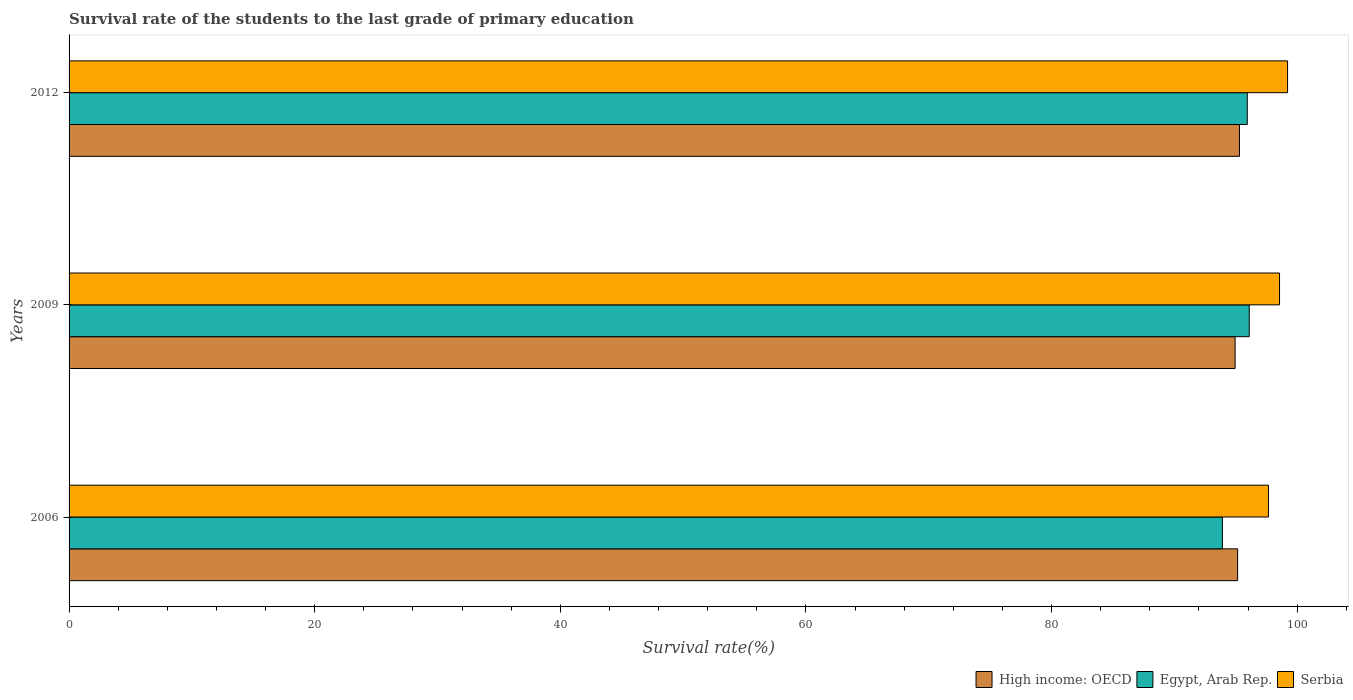Are the number of bars per tick equal to the number of legend labels?
Keep it short and to the point. Yes. Are the number of bars on each tick of the Y-axis equal?
Offer a very short reply. Yes. How many bars are there on the 1st tick from the top?
Give a very brief answer. 3. What is the survival rate of the students in High income: OECD in 2006?
Provide a short and direct response. 95.15. Across all years, what is the maximum survival rate of the students in High income: OECD?
Ensure brevity in your answer.  95.3. Across all years, what is the minimum survival rate of the students in Serbia?
Your answer should be compact. 97.66. In which year was the survival rate of the students in Egypt, Arab Rep. maximum?
Keep it short and to the point. 2009. In which year was the survival rate of the students in Serbia minimum?
Make the answer very short. 2006. What is the total survival rate of the students in Serbia in the graph?
Offer a terse response. 295.44. What is the difference between the survival rate of the students in High income: OECD in 2009 and that in 2012?
Your response must be concise. -0.36. What is the difference between the survival rate of the students in High income: OECD in 2006 and the survival rate of the students in Serbia in 2012?
Provide a succinct answer. -4.07. What is the average survival rate of the students in High income: OECD per year?
Provide a succinct answer. 95.13. In the year 2012, what is the difference between the survival rate of the students in High income: OECD and survival rate of the students in Serbia?
Ensure brevity in your answer.  -3.92. What is the ratio of the survival rate of the students in Serbia in 2006 to that in 2012?
Offer a terse response. 0.98. What is the difference between the highest and the second highest survival rate of the students in Egypt, Arab Rep.?
Ensure brevity in your answer.  0.16. What is the difference between the highest and the lowest survival rate of the students in High income: OECD?
Provide a succinct answer. 0.36. In how many years, is the survival rate of the students in Egypt, Arab Rep. greater than the average survival rate of the students in Egypt, Arab Rep. taken over all years?
Give a very brief answer. 2. Is the sum of the survival rate of the students in Egypt, Arab Rep. in 2009 and 2012 greater than the maximum survival rate of the students in Serbia across all years?
Provide a short and direct response. Yes. What does the 1st bar from the top in 2009 represents?
Offer a terse response. Serbia. What does the 1st bar from the bottom in 2012 represents?
Ensure brevity in your answer.  High income: OECD. How many bars are there?
Offer a terse response. 9. What is the difference between two consecutive major ticks on the X-axis?
Ensure brevity in your answer.  20. Does the graph contain any zero values?
Your answer should be very brief. No. What is the title of the graph?
Keep it short and to the point. Survival rate of the students to the last grade of primary education. Does "Montenegro" appear as one of the legend labels in the graph?
Offer a very short reply. No. What is the label or title of the X-axis?
Provide a short and direct response. Survival rate(%). What is the label or title of the Y-axis?
Make the answer very short. Years. What is the Survival rate(%) in High income: OECD in 2006?
Provide a succinct answer. 95.15. What is the Survival rate(%) in Egypt, Arab Rep. in 2006?
Your answer should be very brief. 93.91. What is the Survival rate(%) in Serbia in 2006?
Give a very brief answer. 97.66. What is the Survival rate(%) in High income: OECD in 2009?
Provide a short and direct response. 94.94. What is the Survival rate(%) of Egypt, Arab Rep. in 2009?
Your answer should be very brief. 96.1. What is the Survival rate(%) of Serbia in 2009?
Your response must be concise. 98.56. What is the Survival rate(%) of High income: OECD in 2012?
Ensure brevity in your answer.  95.3. What is the Survival rate(%) of Egypt, Arab Rep. in 2012?
Keep it short and to the point. 95.94. What is the Survival rate(%) in Serbia in 2012?
Offer a very short reply. 99.22. Across all years, what is the maximum Survival rate(%) of High income: OECD?
Your answer should be compact. 95.3. Across all years, what is the maximum Survival rate(%) of Egypt, Arab Rep.?
Your response must be concise. 96.1. Across all years, what is the maximum Survival rate(%) in Serbia?
Your response must be concise. 99.22. Across all years, what is the minimum Survival rate(%) in High income: OECD?
Ensure brevity in your answer.  94.94. Across all years, what is the minimum Survival rate(%) of Egypt, Arab Rep.?
Your answer should be compact. 93.91. Across all years, what is the minimum Survival rate(%) in Serbia?
Keep it short and to the point. 97.66. What is the total Survival rate(%) of High income: OECD in the graph?
Ensure brevity in your answer.  285.4. What is the total Survival rate(%) of Egypt, Arab Rep. in the graph?
Ensure brevity in your answer.  285.95. What is the total Survival rate(%) in Serbia in the graph?
Your response must be concise. 295.44. What is the difference between the Survival rate(%) of High income: OECD in 2006 and that in 2009?
Keep it short and to the point. 0.2. What is the difference between the Survival rate(%) in Egypt, Arab Rep. in 2006 and that in 2009?
Ensure brevity in your answer.  -2.19. What is the difference between the Survival rate(%) of Serbia in 2006 and that in 2009?
Your answer should be compact. -0.9. What is the difference between the Survival rate(%) in High income: OECD in 2006 and that in 2012?
Your answer should be compact. -0.15. What is the difference between the Survival rate(%) in Egypt, Arab Rep. in 2006 and that in 2012?
Make the answer very short. -2.02. What is the difference between the Survival rate(%) of Serbia in 2006 and that in 2012?
Give a very brief answer. -1.56. What is the difference between the Survival rate(%) of High income: OECD in 2009 and that in 2012?
Keep it short and to the point. -0.36. What is the difference between the Survival rate(%) in Egypt, Arab Rep. in 2009 and that in 2012?
Make the answer very short. 0.16. What is the difference between the Survival rate(%) of Serbia in 2009 and that in 2012?
Provide a succinct answer. -0.65. What is the difference between the Survival rate(%) of High income: OECD in 2006 and the Survival rate(%) of Egypt, Arab Rep. in 2009?
Make the answer very short. -0.95. What is the difference between the Survival rate(%) in High income: OECD in 2006 and the Survival rate(%) in Serbia in 2009?
Offer a terse response. -3.41. What is the difference between the Survival rate(%) in Egypt, Arab Rep. in 2006 and the Survival rate(%) in Serbia in 2009?
Your answer should be compact. -4.65. What is the difference between the Survival rate(%) of High income: OECD in 2006 and the Survival rate(%) of Egypt, Arab Rep. in 2012?
Your answer should be very brief. -0.79. What is the difference between the Survival rate(%) of High income: OECD in 2006 and the Survival rate(%) of Serbia in 2012?
Offer a very short reply. -4.07. What is the difference between the Survival rate(%) of Egypt, Arab Rep. in 2006 and the Survival rate(%) of Serbia in 2012?
Provide a succinct answer. -5.31. What is the difference between the Survival rate(%) in High income: OECD in 2009 and the Survival rate(%) in Egypt, Arab Rep. in 2012?
Your answer should be very brief. -0.99. What is the difference between the Survival rate(%) in High income: OECD in 2009 and the Survival rate(%) in Serbia in 2012?
Give a very brief answer. -4.27. What is the difference between the Survival rate(%) of Egypt, Arab Rep. in 2009 and the Survival rate(%) of Serbia in 2012?
Your answer should be very brief. -3.12. What is the average Survival rate(%) in High income: OECD per year?
Your answer should be compact. 95.13. What is the average Survival rate(%) in Egypt, Arab Rep. per year?
Your answer should be very brief. 95.32. What is the average Survival rate(%) in Serbia per year?
Give a very brief answer. 98.48. In the year 2006, what is the difference between the Survival rate(%) of High income: OECD and Survival rate(%) of Egypt, Arab Rep.?
Your answer should be very brief. 1.24. In the year 2006, what is the difference between the Survival rate(%) of High income: OECD and Survival rate(%) of Serbia?
Provide a short and direct response. -2.51. In the year 2006, what is the difference between the Survival rate(%) in Egypt, Arab Rep. and Survival rate(%) in Serbia?
Your response must be concise. -3.75. In the year 2009, what is the difference between the Survival rate(%) in High income: OECD and Survival rate(%) in Egypt, Arab Rep.?
Your answer should be very brief. -1.15. In the year 2009, what is the difference between the Survival rate(%) in High income: OECD and Survival rate(%) in Serbia?
Your answer should be very brief. -3.62. In the year 2009, what is the difference between the Survival rate(%) in Egypt, Arab Rep. and Survival rate(%) in Serbia?
Ensure brevity in your answer.  -2.46. In the year 2012, what is the difference between the Survival rate(%) of High income: OECD and Survival rate(%) of Egypt, Arab Rep.?
Offer a terse response. -0.63. In the year 2012, what is the difference between the Survival rate(%) of High income: OECD and Survival rate(%) of Serbia?
Provide a short and direct response. -3.92. In the year 2012, what is the difference between the Survival rate(%) in Egypt, Arab Rep. and Survival rate(%) in Serbia?
Provide a short and direct response. -3.28. What is the ratio of the Survival rate(%) of High income: OECD in 2006 to that in 2009?
Your answer should be compact. 1. What is the ratio of the Survival rate(%) in Egypt, Arab Rep. in 2006 to that in 2009?
Ensure brevity in your answer.  0.98. What is the ratio of the Survival rate(%) of Serbia in 2006 to that in 2009?
Ensure brevity in your answer.  0.99. What is the ratio of the Survival rate(%) in High income: OECD in 2006 to that in 2012?
Your response must be concise. 1. What is the ratio of the Survival rate(%) of Egypt, Arab Rep. in 2006 to that in 2012?
Provide a short and direct response. 0.98. What is the ratio of the Survival rate(%) of Serbia in 2006 to that in 2012?
Keep it short and to the point. 0.98. What is the ratio of the Survival rate(%) in High income: OECD in 2009 to that in 2012?
Ensure brevity in your answer.  1. What is the ratio of the Survival rate(%) in Serbia in 2009 to that in 2012?
Your answer should be very brief. 0.99. What is the difference between the highest and the second highest Survival rate(%) of High income: OECD?
Ensure brevity in your answer.  0.15. What is the difference between the highest and the second highest Survival rate(%) in Egypt, Arab Rep.?
Your response must be concise. 0.16. What is the difference between the highest and the second highest Survival rate(%) of Serbia?
Make the answer very short. 0.65. What is the difference between the highest and the lowest Survival rate(%) of High income: OECD?
Provide a succinct answer. 0.36. What is the difference between the highest and the lowest Survival rate(%) of Egypt, Arab Rep.?
Provide a succinct answer. 2.19. What is the difference between the highest and the lowest Survival rate(%) of Serbia?
Provide a short and direct response. 1.56. 